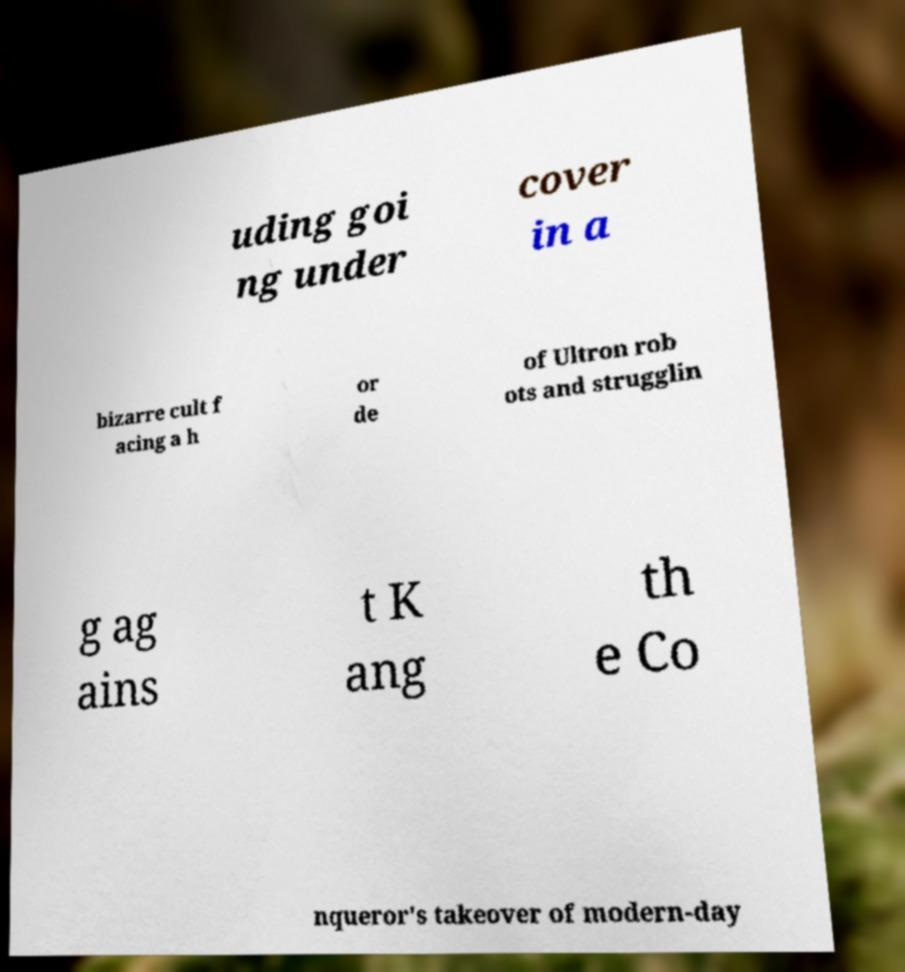Please identify and transcribe the text found in this image. uding goi ng under cover in a bizarre cult f acing a h or de of Ultron rob ots and strugglin g ag ains t K ang th e Co nqueror's takeover of modern-day 